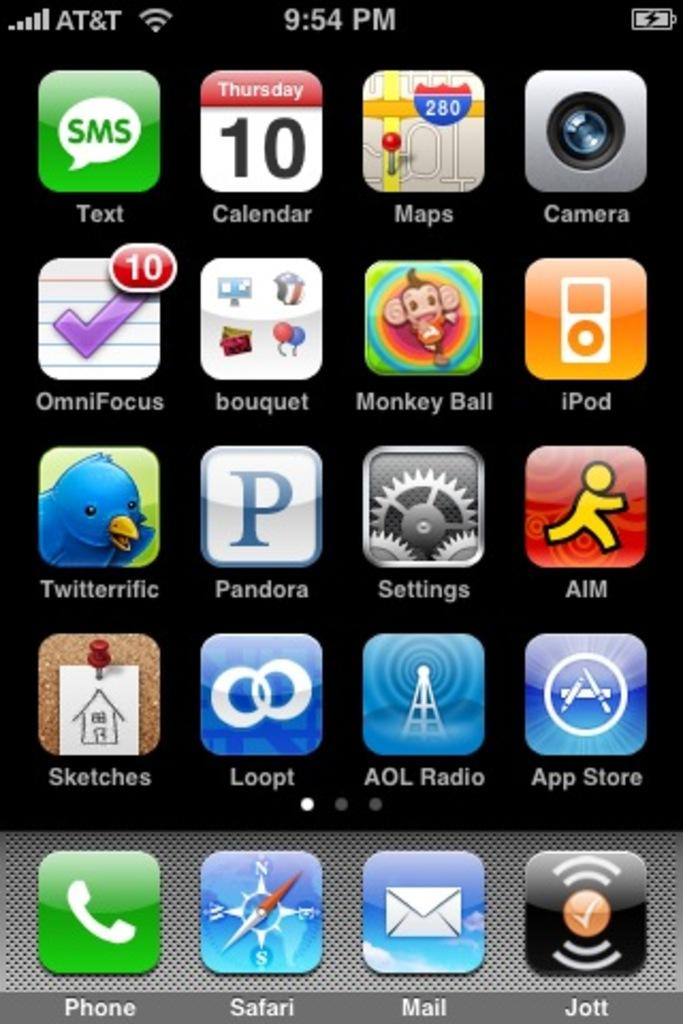<image>
Describe the image concisely. Phone screen that has an app named Jott on the bottom right. 